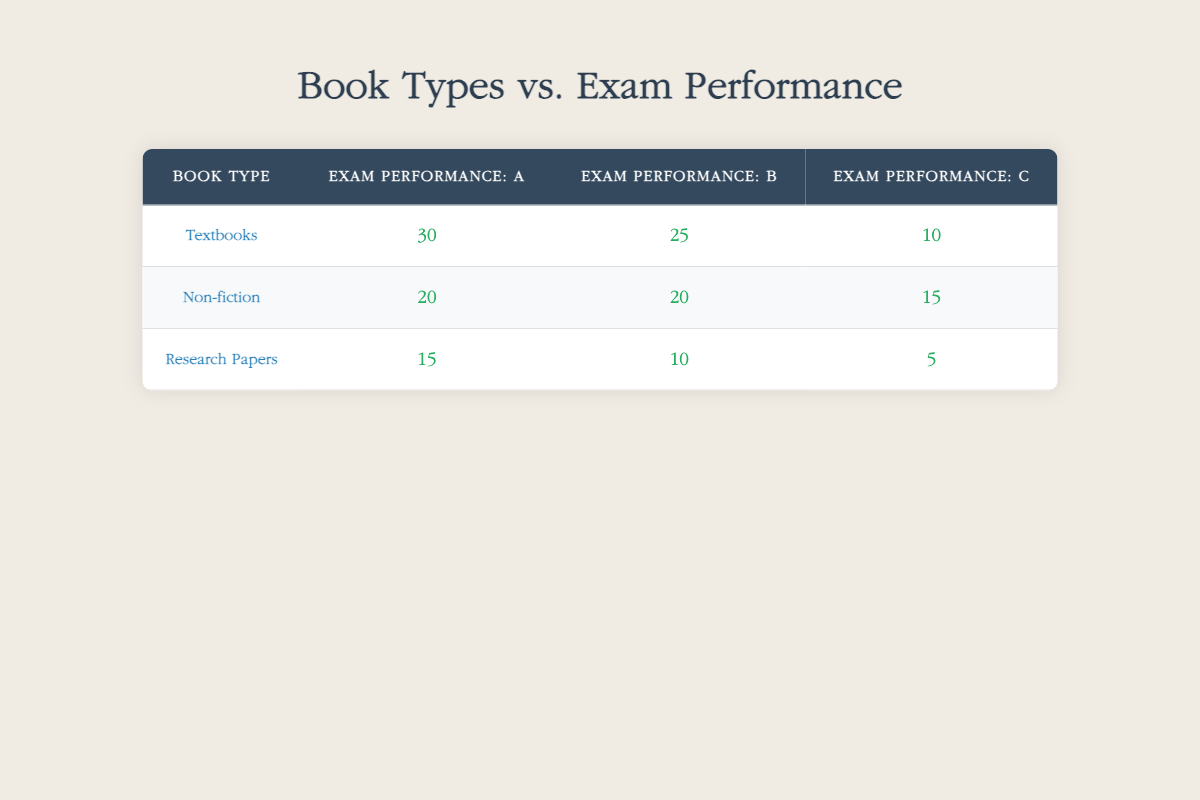What is the count of students who received an A in exam performance for textbooks? Looking at the row for textbooks under the column for exam performance A, the count is 30.
Answer: 30 What are the total counts of students who read non-fiction books and achieved grades A, B, and C? Adding the counts from the non-fiction row: A = 20, B = 20, C = 15. Total = 20 + 20 + 15 = 55.
Answer: 55 Did more students achieve an A in textbooks than in research papers? There are 30 students with an A in textbooks and 15 students with an A in research papers. Since 30 > 15, the statement is true.
Answer: Yes What is the difference in the number of students who received a B in textbooks vs non-fiction? The counts for B are 25 for textbooks and 20 for non-fiction. The difference is 25 - 20 = 5.
Answer: 5 What is the total count of students who received a C grade across all book types? For C grades: Textbooks = 10, Non-fiction = 15, Research Papers = 5. Total = 10 + 15 + 5 = 30.
Answer: 30 Is the count of students who read research papers and received a C greater than those who read textbooks and received a B? The count for research papers C is 5, and for textbooks B is 25. Since 5 is not greater than 25, the statement is false.
Answer: No Which book type had the highest count of students receiving grade A? The highest count for A is found in the textbooks category with 30 students, while non-fiction has 20 and research papers have 15.
Answer: Textbooks What is the average exam performance count for the book type that had the lowest overall exam performance? Research papers have the lowest counts: A = 15, B = 10, C = 5. The average is (15 + 10 + 5) / 3 = 10.
Answer: 10 